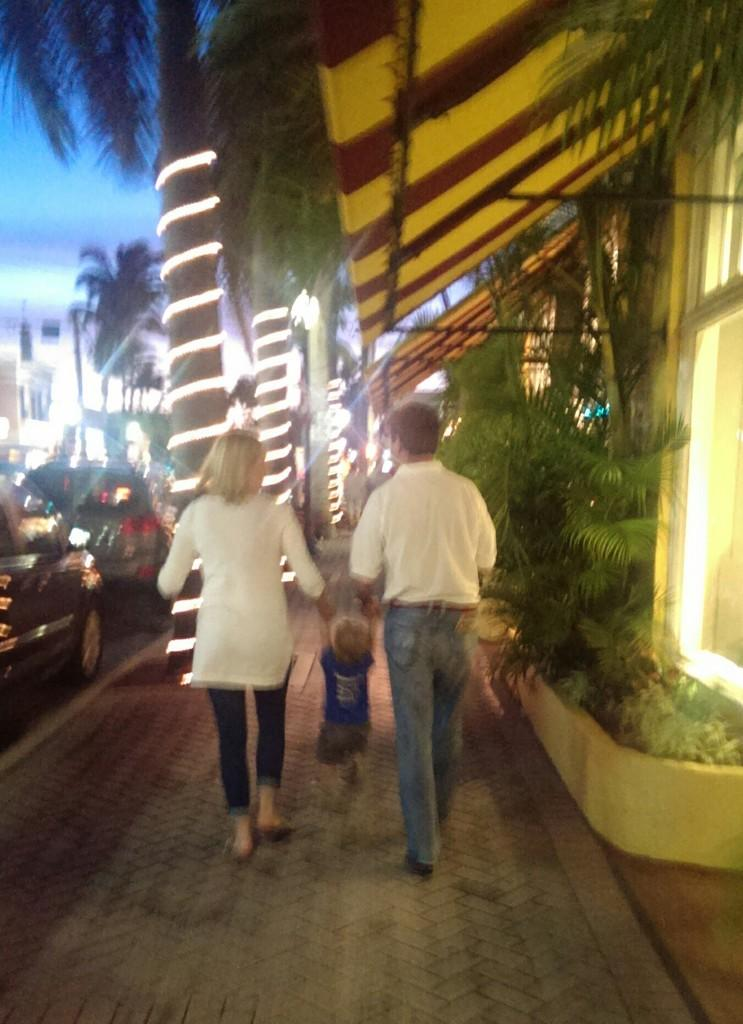How many people are in the image? There are two persons in the image. What are the two persons doing with the kid? The two persons are holding the hands of a kid. What can be seen on the road in the image? There are vehicles on the road in the image. What type of vegetation is present in the image? There are plants and trees in the image. What type of structures can be seen in the image? There are houses in the image. What type of illumination is present in the image? There are lights in the image. What is visible in the sky in the image? The sky is visible in the image. What type of fruit is being used to commit a crime in the image? There is no fruit or crime present in the image. 